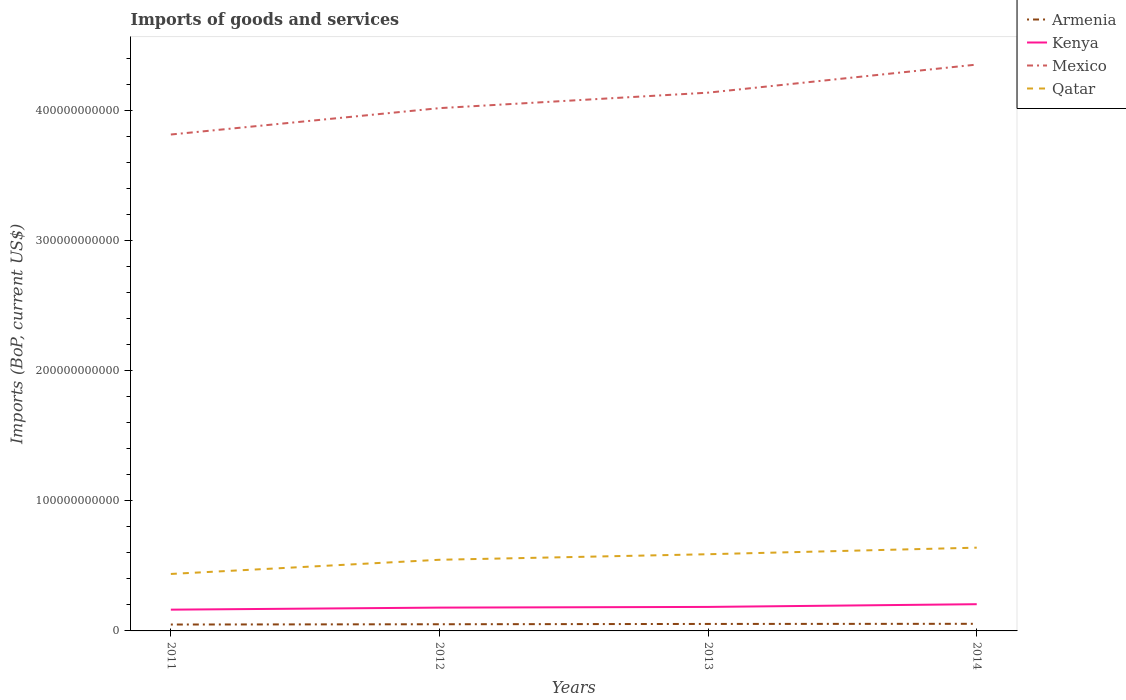How many different coloured lines are there?
Give a very brief answer. 4. Is the number of lines equal to the number of legend labels?
Keep it short and to the point. Yes. Across all years, what is the maximum amount spent on imports in Qatar?
Your answer should be very brief. 4.38e+1. What is the total amount spent on imports in Mexico in the graph?
Offer a very short reply. -2.03e+1. What is the difference between the highest and the second highest amount spent on imports in Qatar?
Give a very brief answer. 2.02e+1. Is the amount spent on imports in Mexico strictly greater than the amount spent on imports in Armenia over the years?
Offer a terse response. No. How many lines are there?
Your answer should be very brief. 4. How many years are there in the graph?
Offer a terse response. 4. What is the difference between two consecutive major ticks on the Y-axis?
Your answer should be very brief. 1.00e+11. Does the graph contain grids?
Your answer should be compact. No. Where does the legend appear in the graph?
Give a very brief answer. Top right. How many legend labels are there?
Offer a terse response. 4. How are the legend labels stacked?
Give a very brief answer. Vertical. What is the title of the graph?
Keep it short and to the point. Imports of goods and services. What is the label or title of the Y-axis?
Keep it short and to the point. Imports (BoP, current US$). What is the Imports (BoP, current US$) in Armenia in 2011?
Provide a succinct answer. 4.92e+09. What is the Imports (BoP, current US$) of Kenya in 2011?
Provide a short and direct response. 1.63e+1. What is the Imports (BoP, current US$) of Mexico in 2011?
Keep it short and to the point. 3.82e+11. What is the Imports (BoP, current US$) in Qatar in 2011?
Ensure brevity in your answer.  4.38e+1. What is the Imports (BoP, current US$) of Armenia in 2012?
Ensure brevity in your answer.  5.13e+09. What is the Imports (BoP, current US$) in Kenya in 2012?
Offer a very short reply. 1.79e+1. What is the Imports (BoP, current US$) in Mexico in 2012?
Provide a succinct answer. 4.02e+11. What is the Imports (BoP, current US$) in Qatar in 2012?
Give a very brief answer. 5.47e+1. What is the Imports (BoP, current US$) in Armenia in 2013?
Your answer should be very brief. 5.36e+09. What is the Imports (BoP, current US$) in Kenya in 2013?
Provide a short and direct response. 1.84e+1. What is the Imports (BoP, current US$) of Mexico in 2013?
Keep it short and to the point. 4.14e+11. What is the Imports (BoP, current US$) in Qatar in 2013?
Your response must be concise. 5.90e+1. What is the Imports (BoP, current US$) of Armenia in 2014?
Make the answer very short. 5.47e+09. What is the Imports (BoP, current US$) in Kenya in 2014?
Your response must be concise. 2.05e+1. What is the Imports (BoP, current US$) in Mexico in 2014?
Offer a terse response. 4.35e+11. What is the Imports (BoP, current US$) of Qatar in 2014?
Offer a terse response. 6.40e+1. Across all years, what is the maximum Imports (BoP, current US$) of Armenia?
Make the answer very short. 5.47e+09. Across all years, what is the maximum Imports (BoP, current US$) in Kenya?
Your answer should be compact. 2.05e+1. Across all years, what is the maximum Imports (BoP, current US$) of Mexico?
Provide a short and direct response. 4.35e+11. Across all years, what is the maximum Imports (BoP, current US$) in Qatar?
Your answer should be compact. 6.40e+1. Across all years, what is the minimum Imports (BoP, current US$) of Armenia?
Your response must be concise. 4.92e+09. Across all years, what is the minimum Imports (BoP, current US$) of Kenya?
Provide a short and direct response. 1.63e+1. Across all years, what is the minimum Imports (BoP, current US$) in Mexico?
Provide a short and direct response. 3.82e+11. Across all years, what is the minimum Imports (BoP, current US$) of Qatar?
Keep it short and to the point. 4.38e+1. What is the total Imports (BoP, current US$) in Armenia in the graph?
Your response must be concise. 2.09e+1. What is the total Imports (BoP, current US$) of Kenya in the graph?
Provide a short and direct response. 7.33e+1. What is the total Imports (BoP, current US$) of Mexico in the graph?
Provide a succinct answer. 1.63e+12. What is the total Imports (BoP, current US$) in Qatar in the graph?
Keep it short and to the point. 2.21e+11. What is the difference between the Imports (BoP, current US$) in Armenia in 2011 and that in 2012?
Provide a succinct answer. -2.14e+08. What is the difference between the Imports (BoP, current US$) of Kenya in 2011 and that in 2012?
Keep it short and to the point. -1.57e+09. What is the difference between the Imports (BoP, current US$) in Mexico in 2011 and that in 2012?
Your response must be concise. -2.03e+1. What is the difference between the Imports (BoP, current US$) in Qatar in 2011 and that in 2012?
Your response must be concise. -1.09e+1. What is the difference between the Imports (BoP, current US$) in Armenia in 2011 and that in 2013?
Give a very brief answer. -4.47e+08. What is the difference between the Imports (BoP, current US$) of Kenya in 2011 and that in 2013?
Provide a succinct answer. -2.10e+09. What is the difference between the Imports (BoP, current US$) in Mexico in 2011 and that in 2013?
Your answer should be compact. -3.22e+1. What is the difference between the Imports (BoP, current US$) in Qatar in 2011 and that in 2013?
Your answer should be compact. -1.52e+1. What is the difference between the Imports (BoP, current US$) in Armenia in 2011 and that in 2014?
Give a very brief answer. -5.50e+08. What is the difference between the Imports (BoP, current US$) in Kenya in 2011 and that in 2014?
Give a very brief answer. -4.19e+09. What is the difference between the Imports (BoP, current US$) of Mexico in 2011 and that in 2014?
Give a very brief answer. -5.38e+1. What is the difference between the Imports (BoP, current US$) in Qatar in 2011 and that in 2014?
Offer a terse response. -2.02e+1. What is the difference between the Imports (BoP, current US$) in Armenia in 2012 and that in 2013?
Offer a terse response. -2.34e+08. What is the difference between the Imports (BoP, current US$) of Kenya in 2012 and that in 2013?
Your answer should be compact. -5.26e+08. What is the difference between the Imports (BoP, current US$) of Mexico in 2012 and that in 2013?
Provide a short and direct response. -1.19e+1. What is the difference between the Imports (BoP, current US$) of Qatar in 2012 and that in 2013?
Ensure brevity in your answer.  -4.26e+09. What is the difference between the Imports (BoP, current US$) in Armenia in 2012 and that in 2014?
Give a very brief answer. -3.36e+08. What is the difference between the Imports (BoP, current US$) in Kenya in 2012 and that in 2014?
Your response must be concise. -2.62e+09. What is the difference between the Imports (BoP, current US$) in Mexico in 2012 and that in 2014?
Give a very brief answer. -3.35e+1. What is the difference between the Imports (BoP, current US$) of Qatar in 2012 and that in 2014?
Offer a very short reply. -9.31e+09. What is the difference between the Imports (BoP, current US$) in Armenia in 2013 and that in 2014?
Keep it short and to the point. -1.03e+08. What is the difference between the Imports (BoP, current US$) in Kenya in 2013 and that in 2014?
Provide a succinct answer. -2.10e+09. What is the difference between the Imports (BoP, current US$) of Mexico in 2013 and that in 2014?
Your answer should be very brief. -2.16e+1. What is the difference between the Imports (BoP, current US$) of Qatar in 2013 and that in 2014?
Ensure brevity in your answer.  -5.05e+09. What is the difference between the Imports (BoP, current US$) in Armenia in 2011 and the Imports (BoP, current US$) in Kenya in 2012?
Your response must be concise. -1.30e+1. What is the difference between the Imports (BoP, current US$) of Armenia in 2011 and the Imports (BoP, current US$) of Mexico in 2012?
Give a very brief answer. -3.97e+11. What is the difference between the Imports (BoP, current US$) in Armenia in 2011 and the Imports (BoP, current US$) in Qatar in 2012?
Your answer should be very brief. -4.98e+1. What is the difference between the Imports (BoP, current US$) of Kenya in 2011 and the Imports (BoP, current US$) of Mexico in 2012?
Provide a short and direct response. -3.86e+11. What is the difference between the Imports (BoP, current US$) of Kenya in 2011 and the Imports (BoP, current US$) of Qatar in 2012?
Your response must be concise. -3.83e+1. What is the difference between the Imports (BoP, current US$) in Mexico in 2011 and the Imports (BoP, current US$) in Qatar in 2012?
Give a very brief answer. 3.27e+11. What is the difference between the Imports (BoP, current US$) in Armenia in 2011 and the Imports (BoP, current US$) in Kenya in 2013?
Your answer should be compact. -1.35e+1. What is the difference between the Imports (BoP, current US$) in Armenia in 2011 and the Imports (BoP, current US$) in Mexico in 2013?
Ensure brevity in your answer.  -4.09e+11. What is the difference between the Imports (BoP, current US$) of Armenia in 2011 and the Imports (BoP, current US$) of Qatar in 2013?
Provide a short and direct response. -5.40e+1. What is the difference between the Imports (BoP, current US$) of Kenya in 2011 and the Imports (BoP, current US$) of Mexico in 2013?
Ensure brevity in your answer.  -3.97e+11. What is the difference between the Imports (BoP, current US$) of Kenya in 2011 and the Imports (BoP, current US$) of Qatar in 2013?
Keep it short and to the point. -4.26e+1. What is the difference between the Imports (BoP, current US$) in Mexico in 2011 and the Imports (BoP, current US$) in Qatar in 2013?
Your response must be concise. 3.23e+11. What is the difference between the Imports (BoP, current US$) of Armenia in 2011 and the Imports (BoP, current US$) of Kenya in 2014?
Ensure brevity in your answer.  -1.56e+1. What is the difference between the Imports (BoP, current US$) of Armenia in 2011 and the Imports (BoP, current US$) of Mexico in 2014?
Provide a short and direct response. -4.30e+11. What is the difference between the Imports (BoP, current US$) of Armenia in 2011 and the Imports (BoP, current US$) of Qatar in 2014?
Provide a short and direct response. -5.91e+1. What is the difference between the Imports (BoP, current US$) in Kenya in 2011 and the Imports (BoP, current US$) in Mexico in 2014?
Make the answer very short. -4.19e+11. What is the difference between the Imports (BoP, current US$) in Kenya in 2011 and the Imports (BoP, current US$) in Qatar in 2014?
Make the answer very short. -4.77e+1. What is the difference between the Imports (BoP, current US$) in Mexico in 2011 and the Imports (BoP, current US$) in Qatar in 2014?
Your answer should be very brief. 3.18e+11. What is the difference between the Imports (BoP, current US$) in Armenia in 2012 and the Imports (BoP, current US$) in Kenya in 2013?
Make the answer very short. -1.33e+1. What is the difference between the Imports (BoP, current US$) of Armenia in 2012 and the Imports (BoP, current US$) of Mexico in 2013?
Your answer should be very brief. -4.09e+11. What is the difference between the Imports (BoP, current US$) in Armenia in 2012 and the Imports (BoP, current US$) in Qatar in 2013?
Your response must be concise. -5.38e+1. What is the difference between the Imports (BoP, current US$) of Kenya in 2012 and the Imports (BoP, current US$) of Mexico in 2013?
Keep it short and to the point. -3.96e+11. What is the difference between the Imports (BoP, current US$) of Kenya in 2012 and the Imports (BoP, current US$) of Qatar in 2013?
Make the answer very short. -4.10e+1. What is the difference between the Imports (BoP, current US$) in Mexico in 2012 and the Imports (BoP, current US$) in Qatar in 2013?
Your answer should be compact. 3.43e+11. What is the difference between the Imports (BoP, current US$) of Armenia in 2012 and the Imports (BoP, current US$) of Kenya in 2014?
Provide a succinct answer. -1.54e+1. What is the difference between the Imports (BoP, current US$) in Armenia in 2012 and the Imports (BoP, current US$) in Mexico in 2014?
Keep it short and to the point. -4.30e+11. What is the difference between the Imports (BoP, current US$) in Armenia in 2012 and the Imports (BoP, current US$) in Qatar in 2014?
Give a very brief answer. -5.89e+1. What is the difference between the Imports (BoP, current US$) in Kenya in 2012 and the Imports (BoP, current US$) in Mexico in 2014?
Your answer should be very brief. -4.17e+11. What is the difference between the Imports (BoP, current US$) in Kenya in 2012 and the Imports (BoP, current US$) in Qatar in 2014?
Keep it short and to the point. -4.61e+1. What is the difference between the Imports (BoP, current US$) of Mexico in 2012 and the Imports (BoP, current US$) of Qatar in 2014?
Keep it short and to the point. 3.38e+11. What is the difference between the Imports (BoP, current US$) of Armenia in 2013 and the Imports (BoP, current US$) of Kenya in 2014?
Keep it short and to the point. -1.52e+1. What is the difference between the Imports (BoP, current US$) in Armenia in 2013 and the Imports (BoP, current US$) in Mexico in 2014?
Offer a very short reply. -4.30e+11. What is the difference between the Imports (BoP, current US$) in Armenia in 2013 and the Imports (BoP, current US$) in Qatar in 2014?
Give a very brief answer. -5.86e+1. What is the difference between the Imports (BoP, current US$) of Kenya in 2013 and the Imports (BoP, current US$) of Mexico in 2014?
Offer a terse response. -4.17e+11. What is the difference between the Imports (BoP, current US$) of Kenya in 2013 and the Imports (BoP, current US$) of Qatar in 2014?
Give a very brief answer. -4.56e+1. What is the difference between the Imports (BoP, current US$) of Mexico in 2013 and the Imports (BoP, current US$) of Qatar in 2014?
Ensure brevity in your answer.  3.50e+11. What is the average Imports (BoP, current US$) in Armenia per year?
Offer a very short reply. 5.22e+09. What is the average Imports (BoP, current US$) in Kenya per year?
Your response must be concise. 1.83e+1. What is the average Imports (BoP, current US$) in Mexico per year?
Your response must be concise. 4.08e+11. What is the average Imports (BoP, current US$) of Qatar per year?
Give a very brief answer. 5.54e+1. In the year 2011, what is the difference between the Imports (BoP, current US$) of Armenia and Imports (BoP, current US$) of Kenya?
Provide a short and direct response. -1.14e+1. In the year 2011, what is the difference between the Imports (BoP, current US$) in Armenia and Imports (BoP, current US$) in Mexico?
Offer a terse response. -3.77e+11. In the year 2011, what is the difference between the Imports (BoP, current US$) in Armenia and Imports (BoP, current US$) in Qatar?
Keep it short and to the point. -3.89e+1. In the year 2011, what is the difference between the Imports (BoP, current US$) of Kenya and Imports (BoP, current US$) of Mexico?
Ensure brevity in your answer.  -3.65e+11. In the year 2011, what is the difference between the Imports (BoP, current US$) in Kenya and Imports (BoP, current US$) in Qatar?
Keep it short and to the point. -2.74e+1. In the year 2011, what is the difference between the Imports (BoP, current US$) of Mexico and Imports (BoP, current US$) of Qatar?
Make the answer very short. 3.38e+11. In the year 2012, what is the difference between the Imports (BoP, current US$) of Armenia and Imports (BoP, current US$) of Kenya?
Your response must be concise. -1.28e+1. In the year 2012, what is the difference between the Imports (BoP, current US$) in Armenia and Imports (BoP, current US$) in Mexico?
Keep it short and to the point. -3.97e+11. In the year 2012, what is the difference between the Imports (BoP, current US$) in Armenia and Imports (BoP, current US$) in Qatar?
Ensure brevity in your answer.  -4.96e+1. In the year 2012, what is the difference between the Imports (BoP, current US$) in Kenya and Imports (BoP, current US$) in Mexico?
Your answer should be very brief. -3.84e+11. In the year 2012, what is the difference between the Imports (BoP, current US$) of Kenya and Imports (BoP, current US$) of Qatar?
Provide a succinct answer. -3.68e+1. In the year 2012, what is the difference between the Imports (BoP, current US$) in Mexico and Imports (BoP, current US$) in Qatar?
Ensure brevity in your answer.  3.47e+11. In the year 2013, what is the difference between the Imports (BoP, current US$) in Armenia and Imports (BoP, current US$) in Kenya?
Keep it short and to the point. -1.31e+1. In the year 2013, what is the difference between the Imports (BoP, current US$) of Armenia and Imports (BoP, current US$) of Mexico?
Give a very brief answer. -4.08e+11. In the year 2013, what is the difference between the Imports (BoP, current US$) of Armenia and Imports (BoP, current US$) of Qatar?
Your response must be concise. -5.36e+1. In the year 2013, what is the difference between the Imports (BoP, current US$) of Kenya and Imports (BoP, current US$) of Mexico?
Ensure brevity in your answer.  -3.95e+11. In the year 2013, what is the difference between the Imports (BoP, current US$) of Kenya and Imports (BoP, current US$) of Qatar?
Provide a short and direct response. -4.05e+1. In the year 2013, what is the difference between the Imports (BoP, current US$) of Mexico and Imports (BoP, current US$) of Qatar?
Give a very brief answer. 3.55e+11. In the year 2014, what is the difference between the Imports (BoP, current US$) in Armenia and Imports (BoP, current US$) in Kenya?
Your answer should be very brief. -1.51e+1. In the year 2014, what is the difference between the Imports (BoP, current US$) of Armenia and Imports (BoP, current US$) of Mexico?
Offer a very short reply. -4.30e+11. In the year 2014, what is the difference between the Imports (BoP, current US$) of Armenia and Imports (BoP, current US$) of Qatar?
Give a very brief answer. -5.85e+1. In the year 2014, what is the difference between the Imports (BoP, current US$) in Kenya and Imports (BoP, current US$) in Mexico?
Ensure brevity in your answer.  -4.15e+11. In the year 2014, what is the difference between the Imports (BoP, current US$) of Kenya and Imports (BoP, current US$) of Qatar?
Your answer should be compact. -4.35e+1. In the year 2014, what is the difference between the Imports (BoP, current US$) of Mexico and Imports (BoP, current US$) of Qatar?
Your answer should be very brief. 3.71e+11. What is the ratio of the Imports (BoP, current US$) in Armenia in 2011 to that in 2012?
Provide a succinct answer. 0.96. What is the ratio of the Imports (BoP, current US$) in Kenya in 2011 to that in 2012?
Keep it short and to the point. 0.91. What is the ratio of the Imports (BoP, current US$) in Mexico in 2011 to that in 2012?
Your answer should be very brief. 0.95. What is the ratio of the Imports (BoP, current US$) of Qatar in 2011 to that in 2012?
Provide a short and direct response. 0.8. What is the ratio of the Imports (BoP, current US$) of Armenia in 2011 to that in 2013?
Offer a terse response. 0.92. What is the ratio of the Imports (BoP, current US$) in Kenya in 2011 to that in 2013?
Keep it short and to the point. 0.89. What is the ratio of the Imports (BoP, current US$) in Mexico in 2011 to that in 2013?
Give a very brief answer. 0.92. What is the ratio of the Imports (BoP, current US$) of Qatar in 2011 to that in 2013?
Provide a short and direct response. 0.74. What is the ratio of the Imports (BoP, current US$) of Armenia in 2011 to that in 2014?
Provide a short and direct response. 0.9. What is the ratio of the Imports (BoP, current US$) in Kenya in 2011 to that in 2014?
Provide a succinct answer. 0.8. What is the ratio of the Imports (BoP, current US$) in Mexico in 2011 to that in 2014?
Offer a very short reply. 0.88. What is the ratio of the Imports (BoP, current US$) in Qatar in 2011 to that in 2014?
Give a very brief answer. 0.68. What is the ratio of the Imports (BoP, current US$) in Armenia in 2012 to that in 2013?
Offer a terse response. 0.96. What is the ratio of the Imports (BoP, current US$) of Kenya in 2012 to that in 2013?
Your response must be concise. 0.97. What is the ratio of the Imports (BoP, current US$) of Mexico in 2012 to that in 2013?
Provide a short and direct response. 0.97. What is the ratio of the Imports (BoP, current US$) of Qatar in 2012 to that in 2013?
Your answer should be compact. 0.93. What is the ratio of the Imports (BoP, current US$) of Armenia in 2012 to that in 2014?
Make the answer very short. 0.94. What is the ratio of the Imports (BoP, current US$) in Kenya in 2012 to that in 2014?
Provide a succinct answer. 0.87. What is the ratio of the Imports (BoP, current US$) in Qatar in 2012 to that in 2014?
Offer a terse response. 0.85. What is the ratio of the Imports (BoP, current US$) in Armenia in 2013 to that in 2014?
Your answer should be very brief. 0.98. What is the ratio of the Imports (BoP, current US$) of Kenya in 2013 to that in 2014?
Provide a succinct answer. 0.9. What is the ratio of the Imports (BoP, current US$) of Mexico in 2013 to that in 2014?
Provide a short and direct response. 0.95. What is the ratio of the Imports (BoP, current US$) of Qatar in 2013 to that in 2014?
Offer a terse response. 0.92. What is the difference between the highest and the second highest Imports (BoP, current US$) in Armenia?
Offer a very short reply. 1.03e+08. What is the difference between the highest and the second highest Imports (BoP, current US$) in Kenya?
Your answer should be compact. 2.10e+09. What is the difference between the highest and the second highest Imports (BoP, current US$) in Mexico?
Provide a succinct answer. 2.16e+1. What is the difference between the highest and the second highest Imports (BoP, current US$) in Qatar?
Your answer should be very brief. 5.05e+09. What is the difference between the highest and the lowest Imports (BoP, current US$) of Armenia?
Your response must be concise. 5.50e+08. What is the difference between the highest and the lowest Imports (BoP, current US$) in Kenya?
Provide a succinct answer. 4.19e+09. What is the difference between the highest and the lowest Imports (BoP, current US$) of Mexico?
Make the answer very short. 5.38e+1. What is the difference between the highest and the lowest Imports (BoP, current US$) in Qatar?
Offer a terse response. 2.02e+1. 